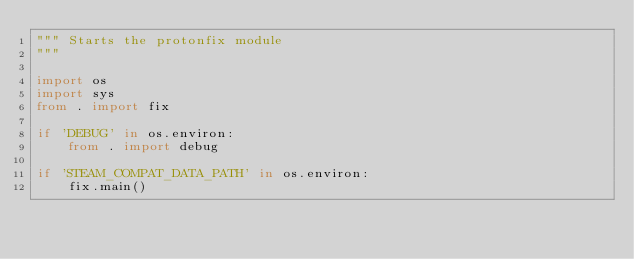Convert code to text. <code><loc_0><loc_0><loc_500><loc_500><_Python_>""" Starts the protonfix module
"""

import os
import sys
from . import fix

if 'DEBUG' in os.environ:
    from . import debug

if 'STEAM_COMPAT_DATA_PATH' in os.environ:
    fix.main()
</code> 